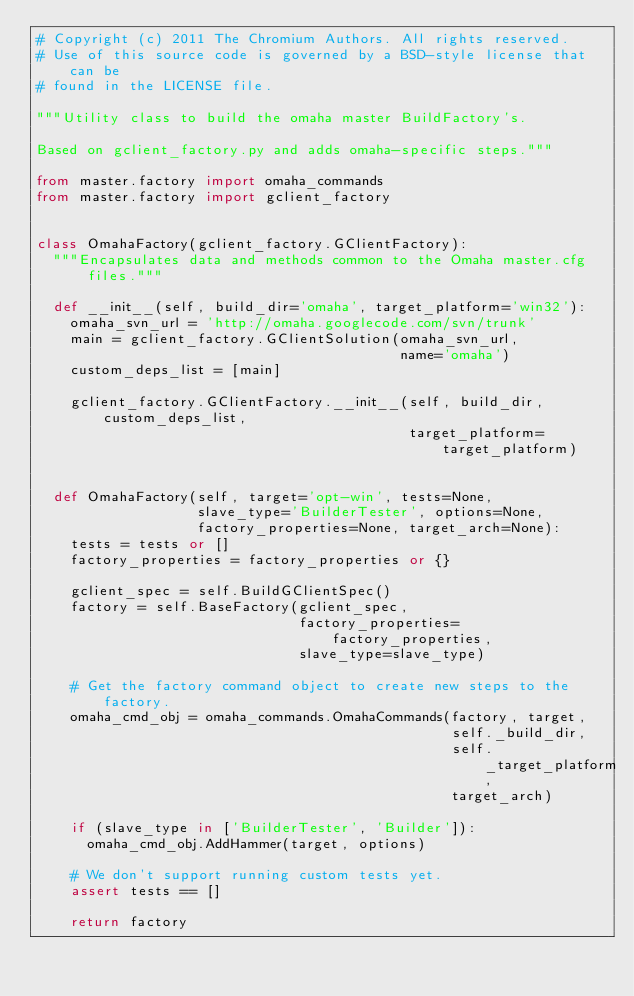<code> <loc_0><loc_0><loc_500><loc_500><_Python_># Copyright (c) 2011 The Chromium Authors. All rights reserved.
# Use of this source code is governed by a BSD-style license that can be
# found in the LICENSE file.

"""Utility class to build the omaha master BuildFactory's.

Based on gclient_factory.py and adds omaha-specific steps."""

from master.factory import omaha_commands
from master.factory import gclient_factory


class OmahaFactory(gclient_factory.GClientFactory):
  """Encapsulates data and methods common to the Omaha master.cfg files."""

  def __init__(self, build_dir='omaha', target_platform='win32'):
    omaha_svn_url = 'http://omaha.googlecode.com/svn/trunk'
    main = gclient_factory.GClientSolution(omaha_svn_url,
                                           name='omaha')
    custom_deps_list = [main]

    gclient_factory.GClientFactory.__init__(self, build_dir, custom_deps_list,
                                            target_platform=target_platform)


  def OmahaFactory(self, target='opt-win', tests=None,
                   slave_type='BuilderTester', options=None,
                   factory_properties=None, target_arch=None):
    tests = tests or []
    factory_properties = factory_properties or {}

    gclient_spec = self.BuildGClientSpec()
    factory = self.BaseFactory(gclient_spec,
                               factory_properties=factory_properties,
                               slave_type=slave_type)

    # Get the factory command object to create new steps to the factory.
    omaha_cmd_obj = omaha_commands.OmahaCommands(factory, target,
                                                 self._build_dir,
                                                 self._target_platform,
                                                 target_arch)

    if (slave_type in ['BuilderTester', 'Builder']):
      omaha_cmd_obj.AddHammer(target, options)

    # We don't support running custom tests yet.
    assert tests == []

    return factory
</code> 